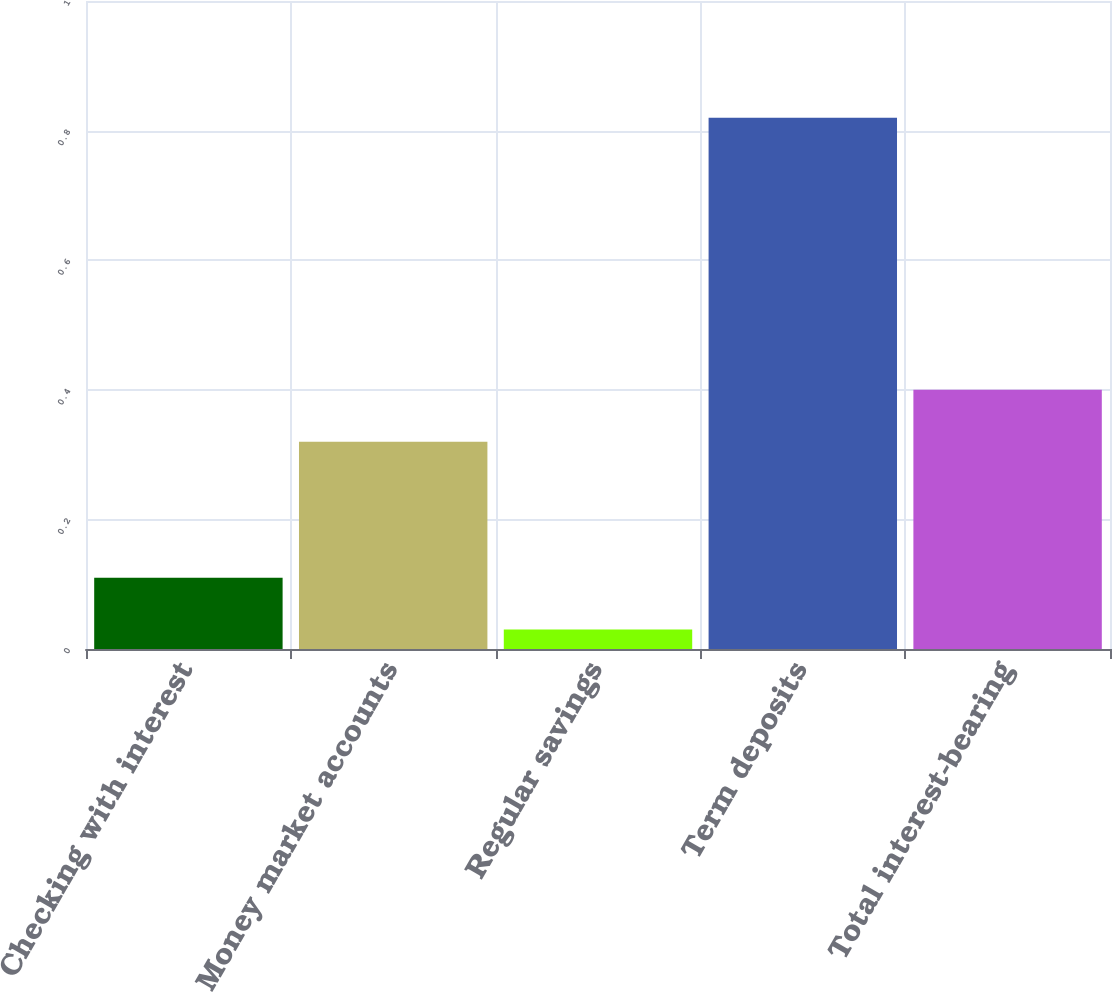Convert chart to OTSL. <chart><loc_0><loc_0><loc_500><loc_500><bar_chart><fcel>Checking with interest<fcel>Money market accounts<fcel>Regular savings<fcel>Term deposits<fcel>Total interest-bearing<nl><fcel>0.11<fcel>0.32<fcel>0.03<fcel>0.82<fcel>0.4<nl></chart> 